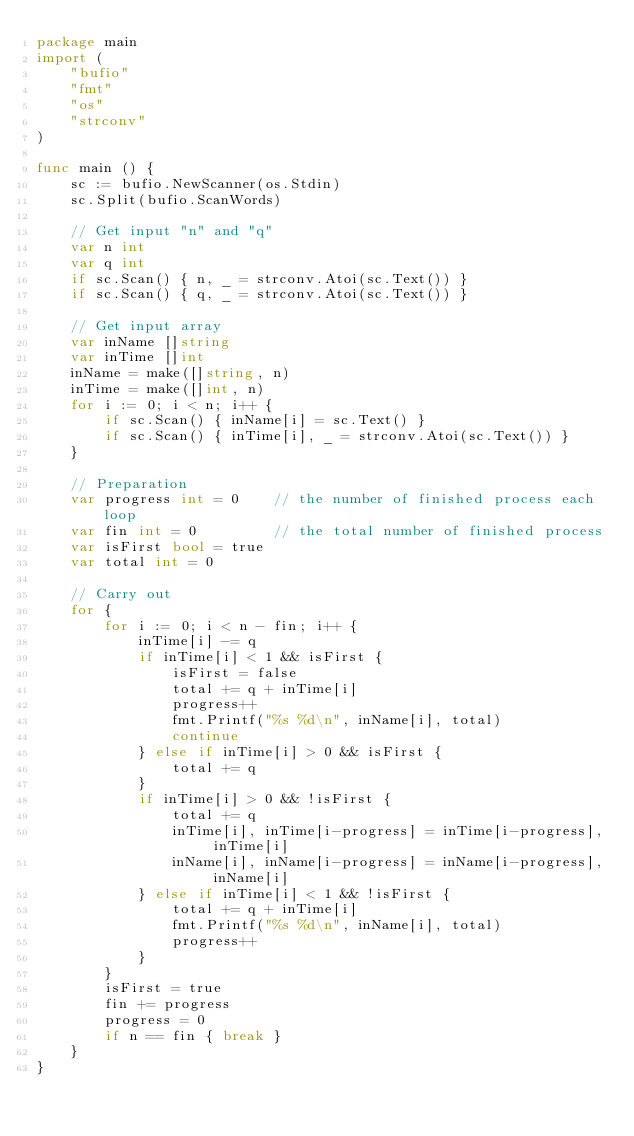<code> <loc_0><loc_0><loc_500><loc_500><_Go_>package main
import (
    "bufio"
    "fmt"
    "os"
    "strconv"
)

func main () {
    sc := bufio.NewScanner(os.Stdin)
    sc.Split(bufio.ScanWords)

    // Get input "n" and "q"
    var n int
    var q int
    if sc.Scan() { n, _ = strconv.Atoi(sc.Text()) }
    if sc.Scan() { q, _ = strconv.Atoi(sc.Text()) }

    // Get input array
    var inName []string
    var inTime []int
    inName = make([]string, n)
    inTime = make([]int, n)
    for i := 0; i < n; i++ {
        if sc.Scan() { inName[i] = sc.Text() }
        if sc.Scan() { inTime[i], _ = strconv.Atoi(sc.Text()) }
    }

    // Preparation
    var progress int = 0    // the number of finished process each loop
    var fin int = 0         // the total number of finished process
    var isFirst bool = true
    var total int = 0

    // Carry out
    for {
        for i := 0; i < n - fin; i++ {
            inTime[i] -= q
            if inTime[i] < 1 && isFirst {
                isFirst = false
                total += q + inTime[i]
                progress++
                fmt.Printf("%s %d\n", inName[i], total)
                continue
            } else if inTime[i] > 0 && isFirst {
                total += q
            }
            if inTime[i] > 0 && !isFirst {
                total += q
                inTime[i], inTime[i-progress] = inTime[i-progress], inTime[i]
                inName[i], inName[i-progress] = inName[i-progress], inName[i]
            } else if inTime[i] < 1 && !isFirst {
                total += q + inTime[i]
                fmt.Printf("%s %d\n", inName[i], total)
                progress++
            }
        }
        isFirst = true
        fin += progress
        progress = 0
        if n == fin { break }
    }
}

</code> 